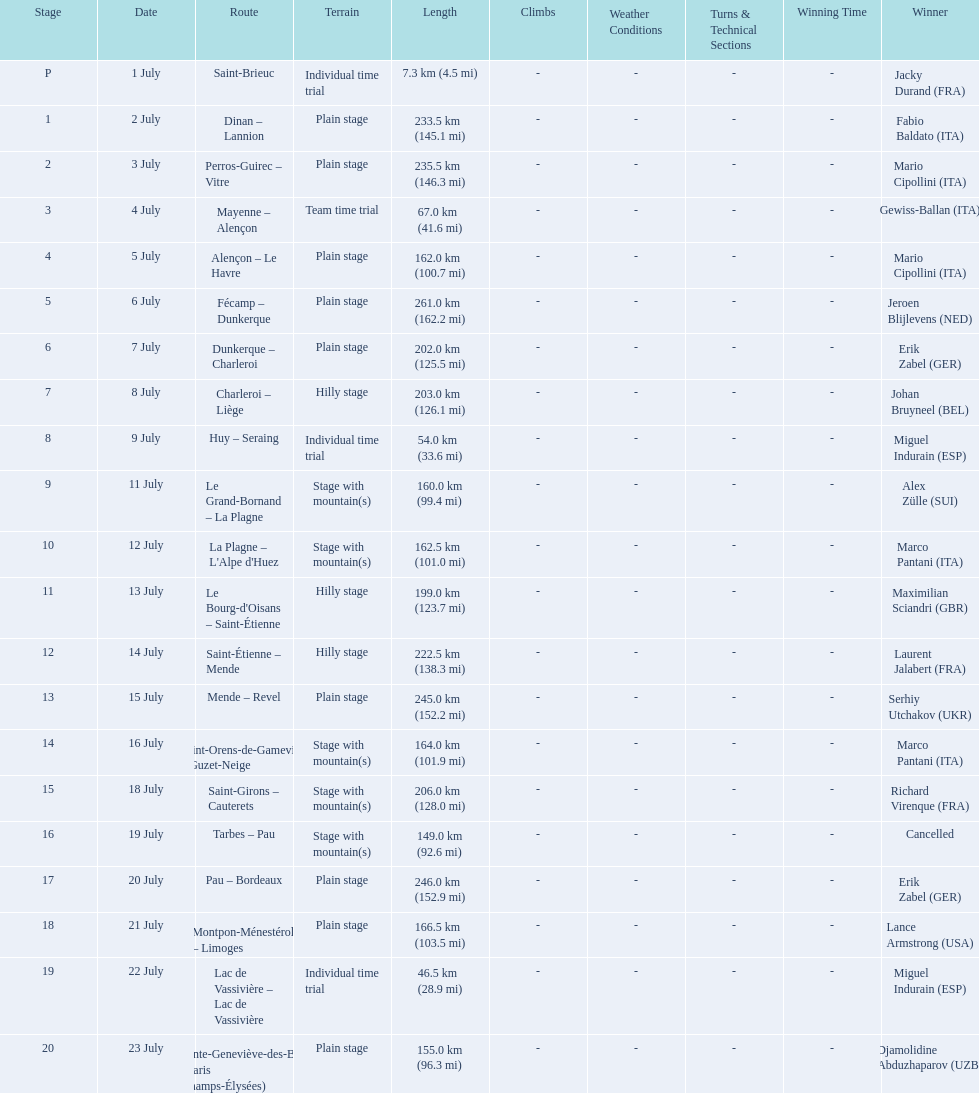What were the dates of the 1995 tour de france? 1 July, 2 July, 3 July, 4 July, 5 July, 6 July, 7 July, 8 July, 9 July, 11 July, 12 July, 13 July, 14 July, 15 July, 16 July, 18 July, 19 July, 20 July, 21 July, 22 July, 23 July. What was the length for july 8th? 203.0 km (126.1 mi). 